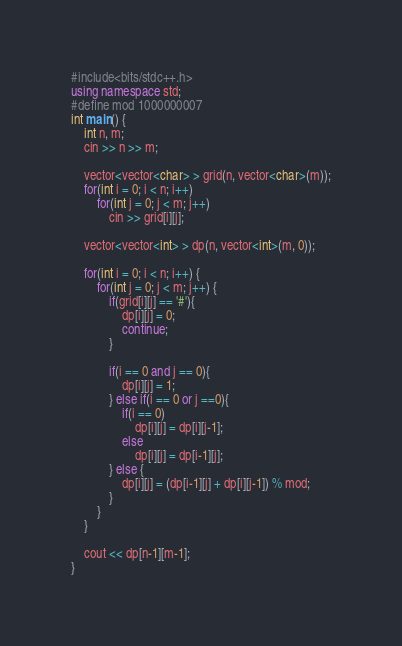<code> <loc_0><loc_0><loc_500><loc_500><_C++_>#include<bits/stdc++.h>
using namespace std;
#define mod 1000000007
int main() {
    int n, m;
    cin >> n >> m;
    
    vector<vector<char> > grid(n, vector<char>(m));
    for(int i = 0; i < n; i++)
        for(int j = 0; j < m; j++)
            cin >> grid[i][j];
    
    vector<vector<int> > dp(n, vector<int>(m, 0));
    
    for(int i = 0; i < n; i++) {
        for(int j = 0; j < m; j++) {
            if(grid[i][j] == '#'){
                dp[i][j] = 0;
                continue;
            }

            if(i == 0 and j == 0){
                dp[i][j] = 1;
            } else if(i == 0 or j ==0){
                if(i == 0)
                    dp[i][j] = dp[i][j-1];
                else
                    dp[i][j] = dp[i-1][j];
            } else {
                dp[i][j] = (dp[i-1][j] + dp[i][j-1]) % mod;
            }
        }
    }
    
    cout << dp[n-1][m-1];
}</code> 